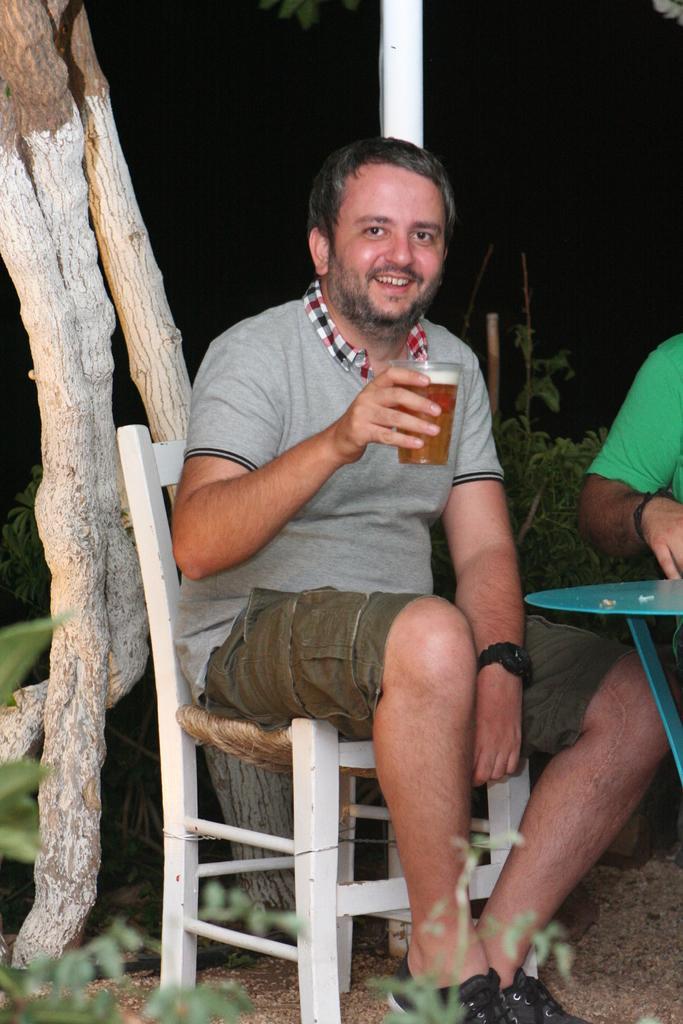Describe this image in one or two sentences. There is a man at the given picture, sitting in a chair, holding a glass with a drink in it. He's smiling. In front of him there is a table. In the background there is a tree and a pole here. 